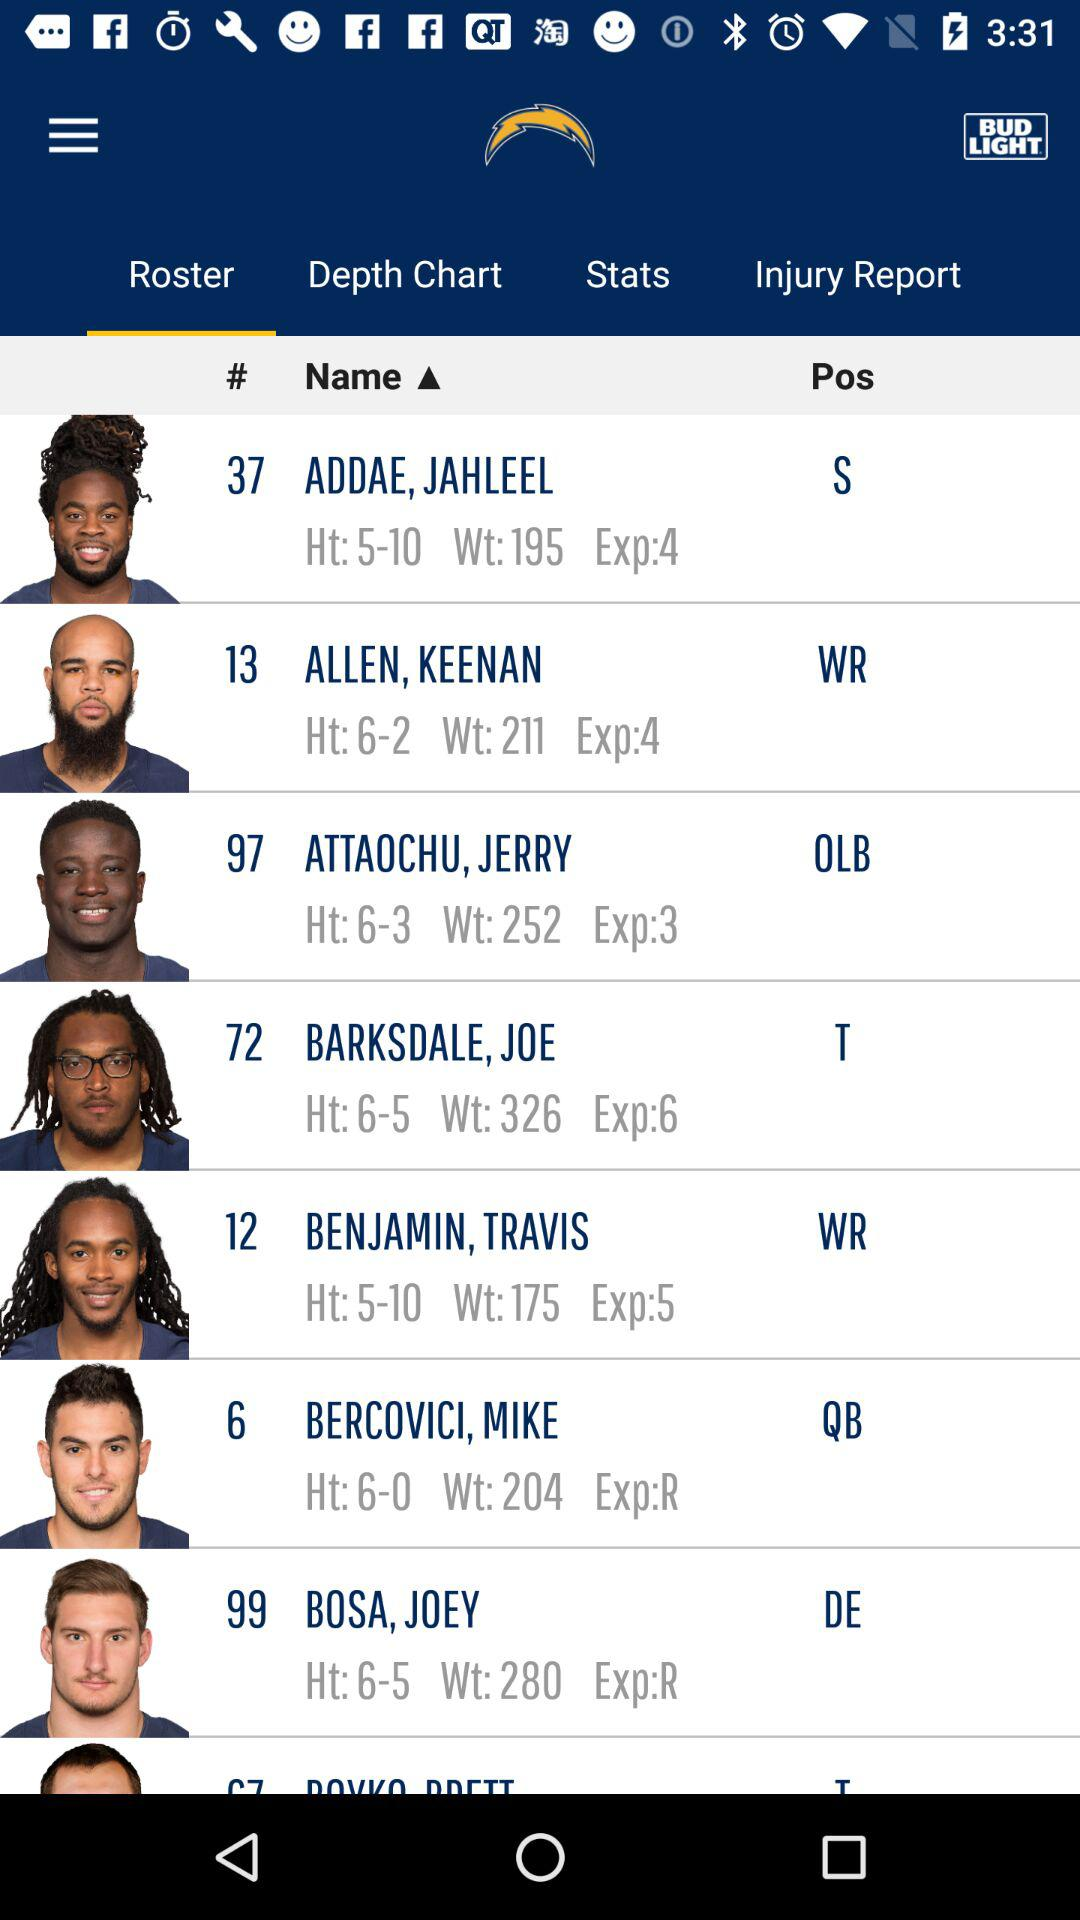Which player has the jersey number 99? The player is Joey Bosa. 